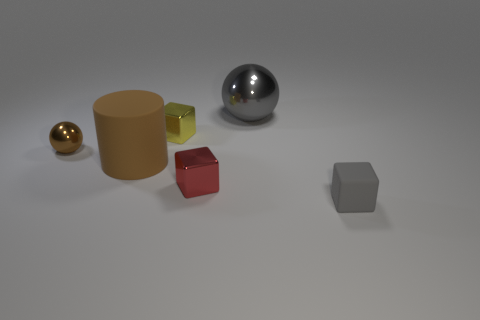What's the geometric shape of the transparent object? The transparent object has the geometric shape of a cube. Despite its transparency, the edges and flat surfaces are quite noticeable. 